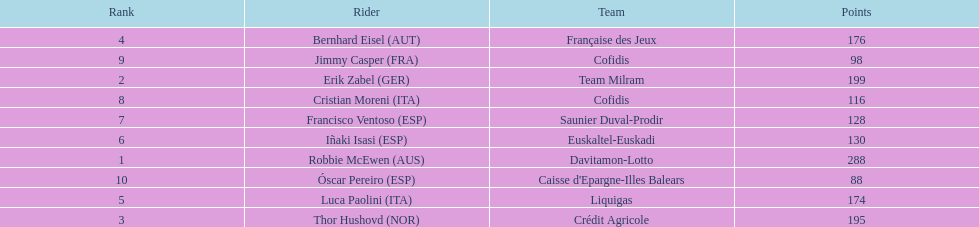How many more points did erik zabel score than franciso ventoso? 71. 